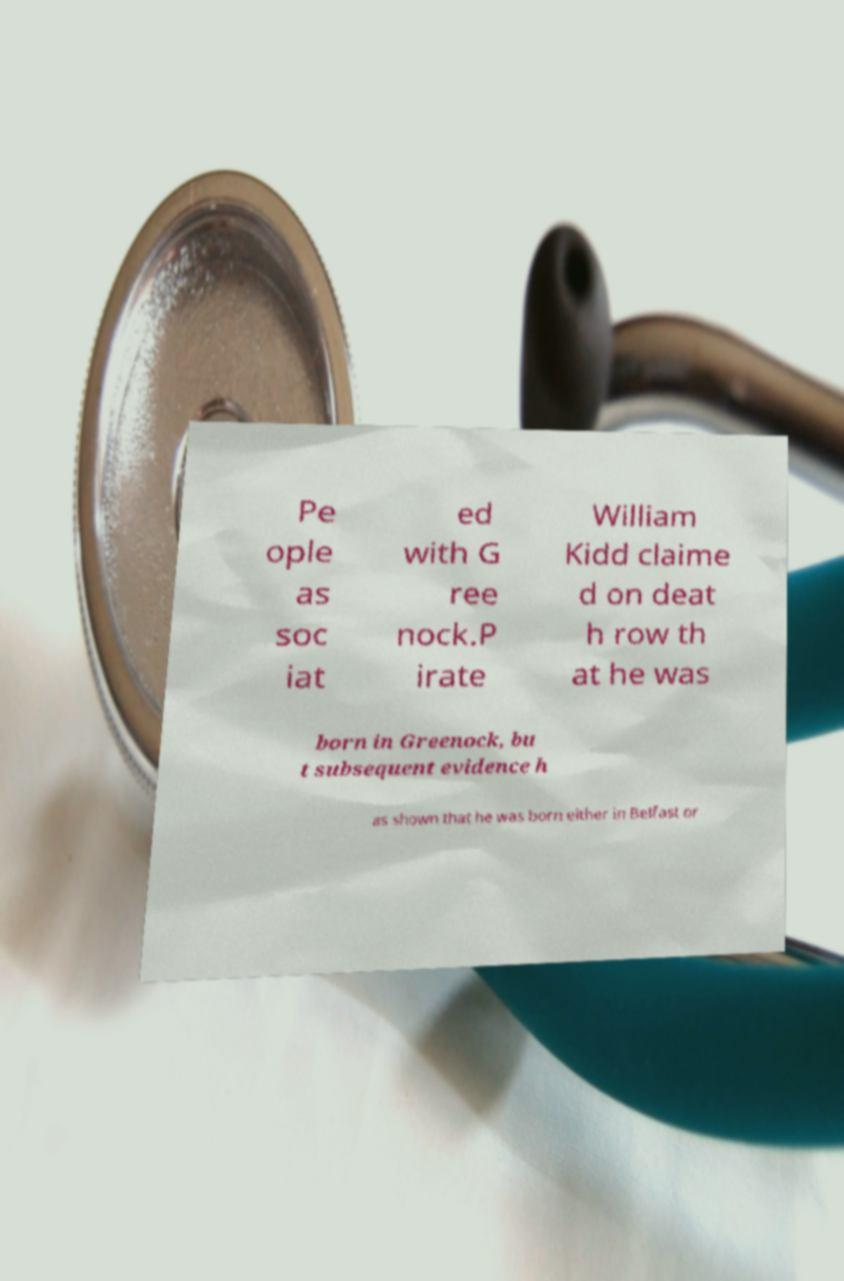There's text embedded in this image that I need extracted. Can you transcribe it verbatim? Pe ople as soc iat ed with G ree nock.P irate William Kidd claime d on deat h row th at he was born in Greenock, bu t subsequent evidence h as shown that he was born either in Belfast or 